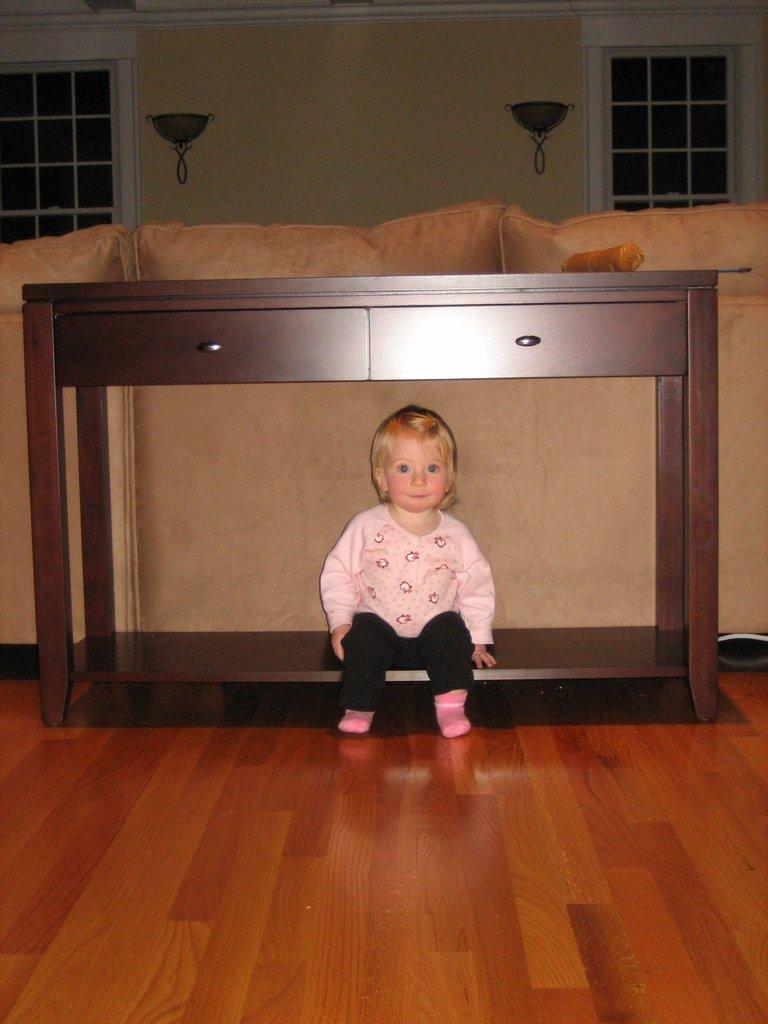What is the girl in the image doing? The girl is sitting in the image. Where is the girl sitting? The girl is sitting under a table. What is the table resting on? The table is placed on the floor. What can be seen on the wall in the image? There is a window in the wall. What type of organization does the girl belong to in the image? There is no information about the girl's organization in the image. How does the society depicted in the image affect the girl's behavior? There is no society depicted in the image, and therefore its impact on the girl's behavior cannot be determined. 